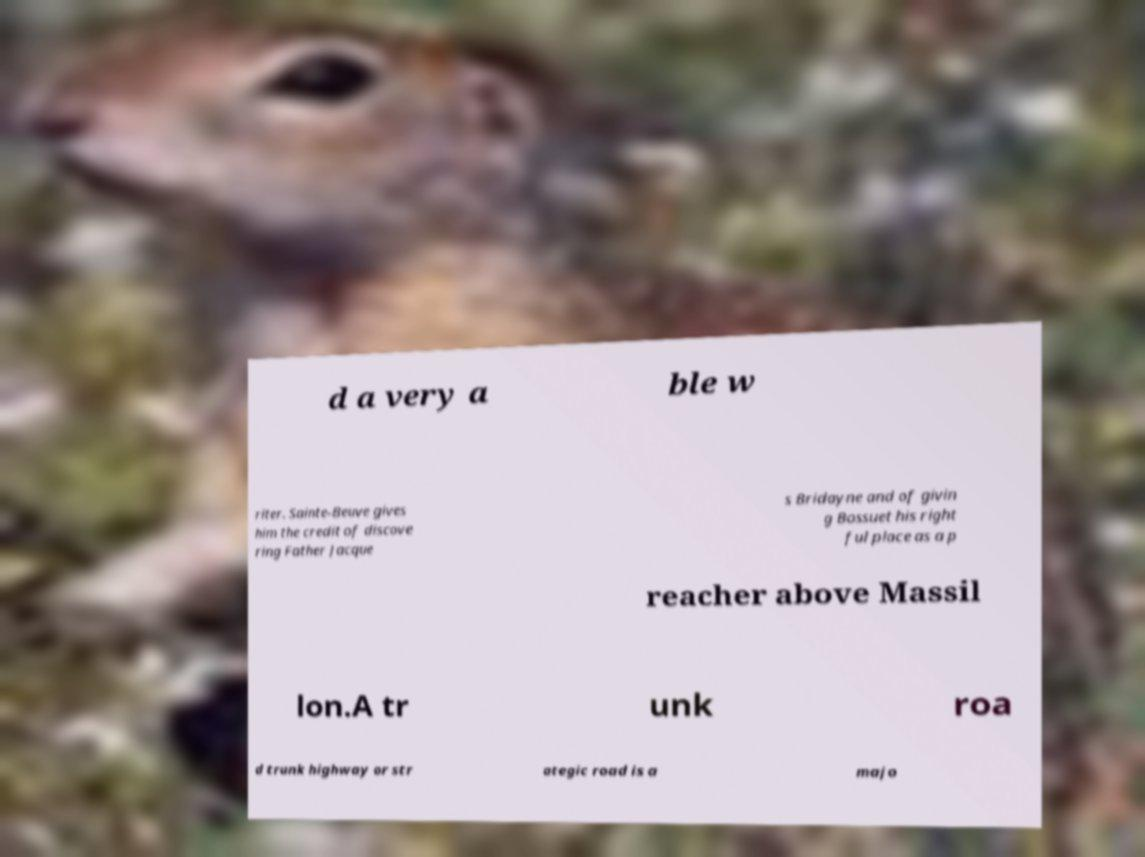For documentation purposes, I need the text within this image transcribed. Could you provide that? d a very a ble w riter. Sainte-Beuve gives him the credit of discove ring Father Jacque s Bridayne and of givin g Bossuet his right ful place as a p reacher above Massil lon.A tr unk roa d trunk highway or str ategic road is a majo 